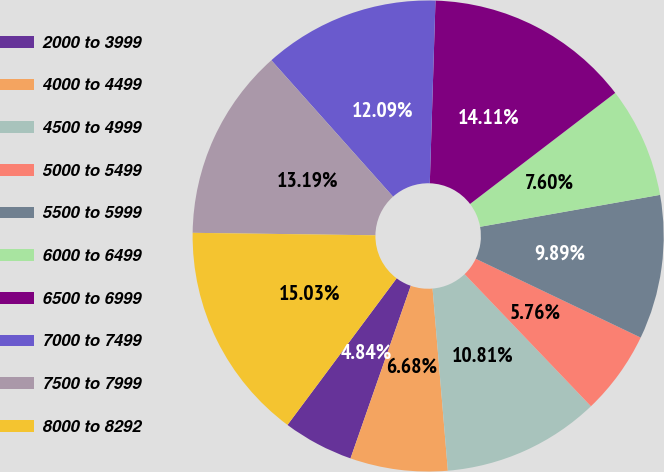Convert chart. <chart><loc_0><loc_0><loc_500><loc_500><pie_chart><fcel>2000 to 3999<fcel>4000 to 4499<fcel>4500 to 4999<fcel>5000 to 5499<fcel>5500 to 5999<fcel>6000 to 6499<fcel>6500 to 6999<fcel>7000 to 7499<fcel>7500 to 7999<fcel>8000 to 8292<nl><fcel>4.84%<fcel>6.68%<fcel>10.81%<fcel>5.76%<fcel>9.89%<fcel>7.6%<fcel>14.11%<fcel>12.09%<fcel>13.19%<fcel>15.03%<nl></chart> 